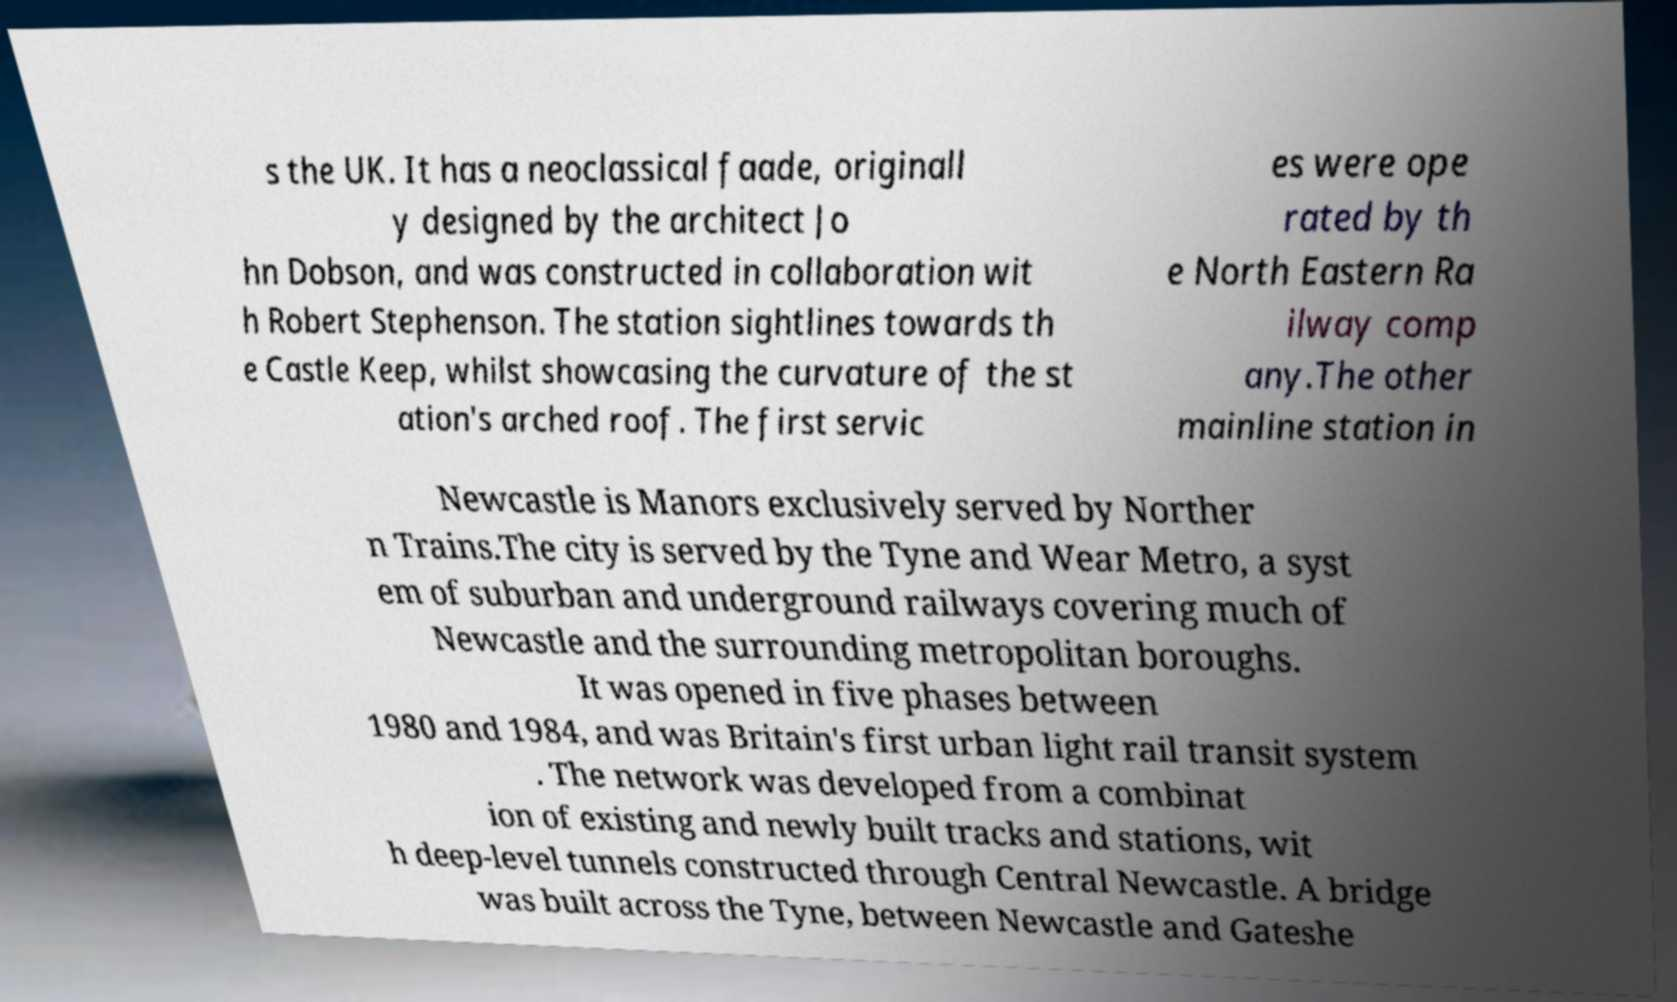There's text embedded in this image that I need extracted. Can you transcribe it verbatim? s the UK. It has a neoclassical faade, originall y designed by the architect Jo hn Dobson, and was constructed in collaboration wit h Robert Stephenson. The station sightlines towards th e Castle Keep, whilst showcasing the curvature of the st ation's arched roof. The first servic es were ope rated by th e North Eastern Ra ilway comp any.The other mainline station in Newcastle is Manors exclusively served by Norther n Trains.The city is served by the Tyne and Wear Metro, a syst em of suburban and underground railways covering much of Newcastle and the surrounding metropolitan boroughs. It was opened in five phases between 1980 and 1984, and was Britain's first urban light rail transit system . The network was developed from a combinat ion of existing and newly built tracks and stations, wit h deep-level tunnels constructed through Central Newcastle. A bridge was built across the Tyne, between Newcastle and Gateshe 